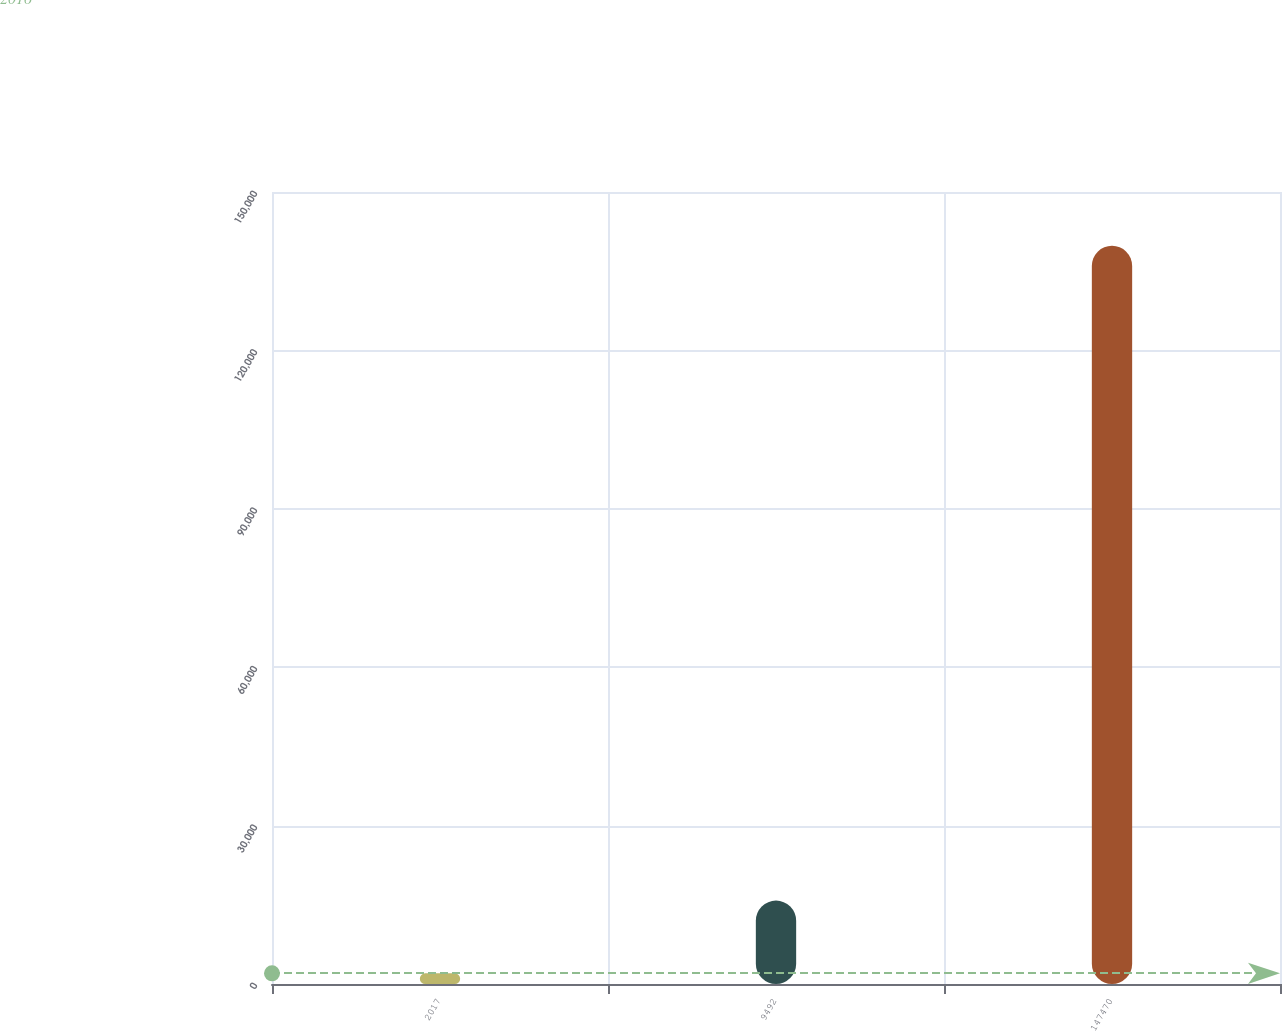Convert chart. <chart><loc_0><loc_0><loc_500><loc_500><bar_chart><fcel>2017<fcel>9492<fcel>147470<nl><fcel>2016<fcel>15796.5<fcel>139821<nl></chart> 